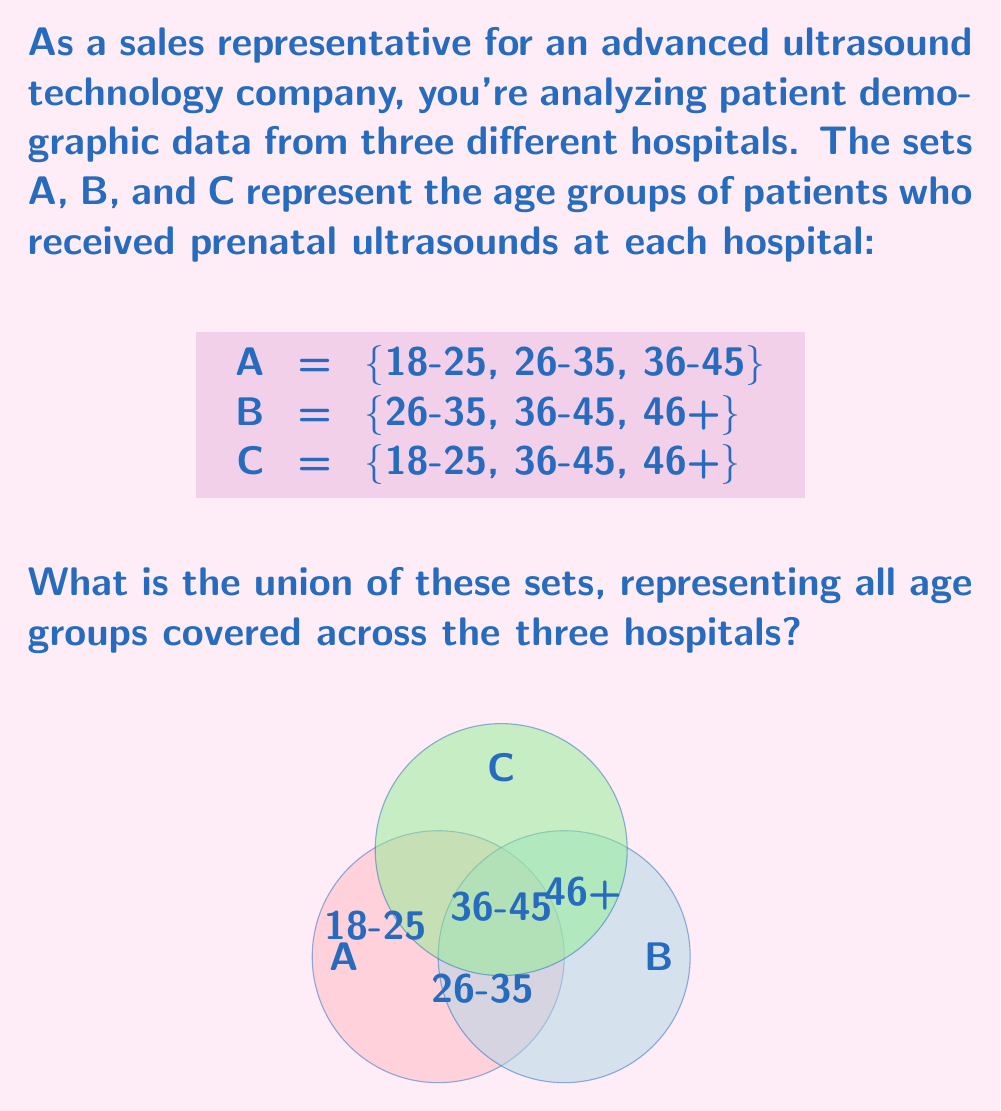Help me with this question. To find the union of sets A, B, and C, we need to combine all unique elements from each set. Let's approach this step-by-step:

1) First, let's list out the elements of each set:
   A = {18-25, 26-35, 36-45}
   B = {26-35, 36-45, 46+}
   C = {18-25, 36-45, 46+}

2) The union of these sets, denoted as $A \cup B \cup C$, will include all unique elements from all sets.

3) Let's start with set A and add unique elements from B and C:
   - From A: 18-25, 26-35, 36-45
   - From B: 46+ (new element not in A)
   - From C: No new elements (all already included)

4) Therefore, the union of all sets includes:
   $A \cup B \cup C = \{18-25, 26-35, 36-45, 46+\}$

This union represents all age groups of patients who received prenatal ultrasounds across the three hospitals.
Answer: $\{18-25, 26-35, 36-45, 46+\}$ 